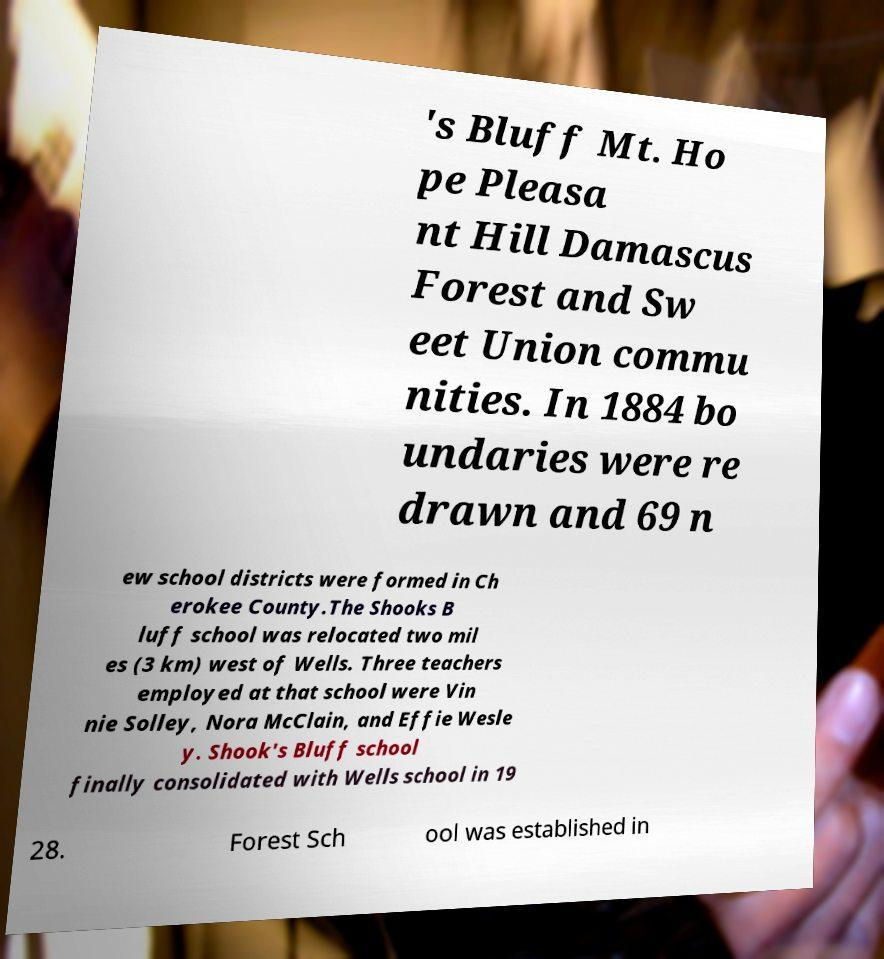I need the written content from this picture converted into text. Can you do that? 's Bluff Mt. Ho pe Pleasa nt Hill Damascus Forest and Sw eet Union commu nities. In 1884 bo undaries were re drawn and 69 n ew school districts were formed in Ch erokee County.The Shooks B luff school was relocated two mil es (3 km) west of Wells. Three teachers employed at that school were Vin nie Solley, Nora McClain, and Effie Wesle y. Shook's Bluff school finally consolidated with Wells school in 19 28. Forest Sch ool was established in 